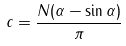<formula> <loc_0><loc_0><loc_500><loc_500>c = \frac { N ( \alpha - \sin \alpha ) } \pi</formula> 